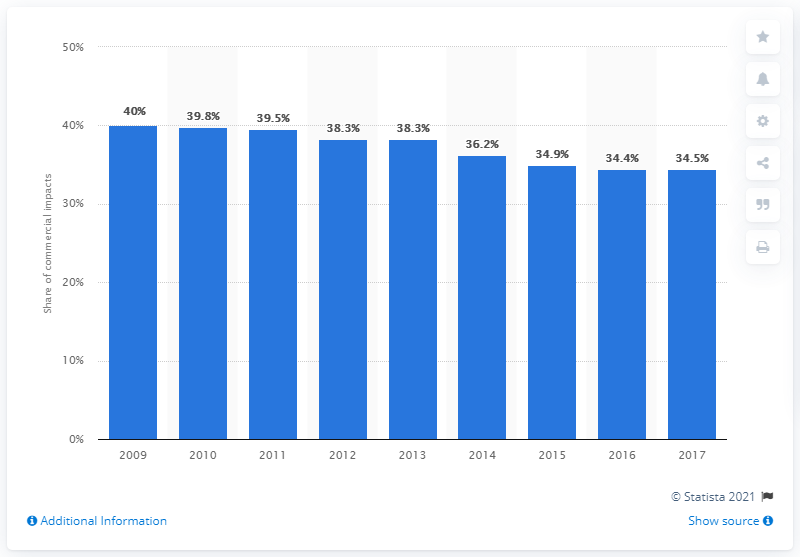List a handful of essential elements in this visual. In 2017, ITV family SOCI dropped by 34.5% of its total UK television commercial impact. In 2013, the ITV family (Independent Television) accounted for 38.3% of the total impact of television commercials in the UK. 